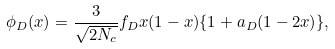<formula> <loc_0><loc_0><loc_500><loc_500>\phi _ { D } ( x ) = \frac { 3 } { \sqrt { 2 N _ { c } } } f _ { D } x ( 1 - x ) \{ 1 + a _ { D } ( 1 - 2 x ) \} ,</formula> 